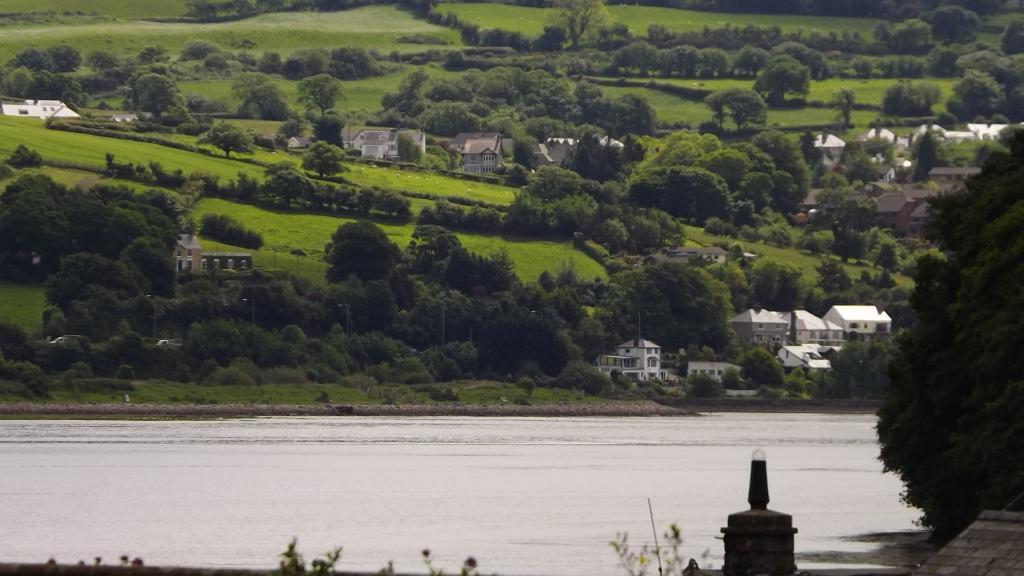What is the main feature of the landscape in the image? There is a big lake in the image. What type of vegetation can be seen in the image? There are trees in the image. What type of man-made structures are present in the image? There are buildings in the image. What type of map can be seen floating on the lake in the image? There is no map present in the image; it features a big lake, trees, and buildings. What color is the marble used to decorate the buildings in the image? There is no marble present in the image; the buildings are not described in terms of their decorative elements. 